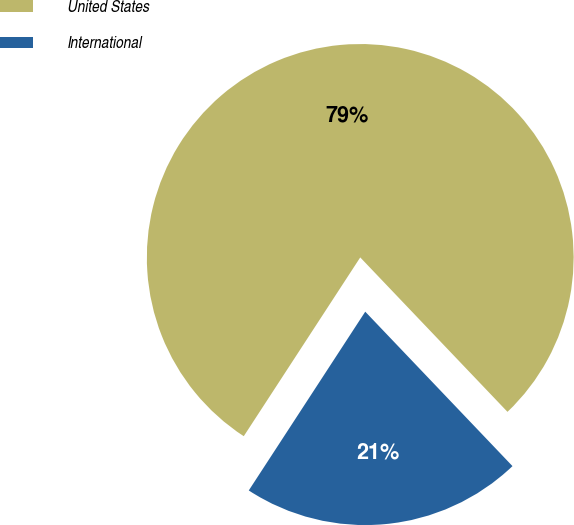<chart> <loc_0><loc_0><loc_500><loc_500><pie_chart><fcel>United States<fcel>International<nl><fcel>78.69%<fcel>21.31%<nl></chart> 